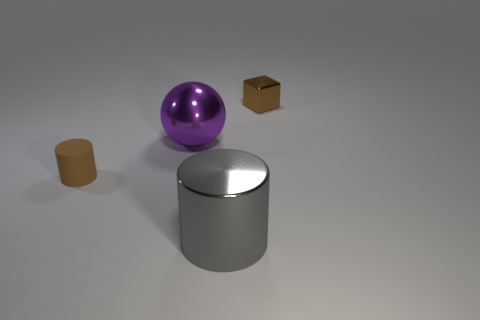Considering the positions of the objects in the image, what kind of story or setting could this illustrate? The objects might represent a minimalist art installation highlighting shapes and textures. The solitary placement of the objects across a wide space could allude to a theme of isolation or the concept of individuality in a homogenous environment. 